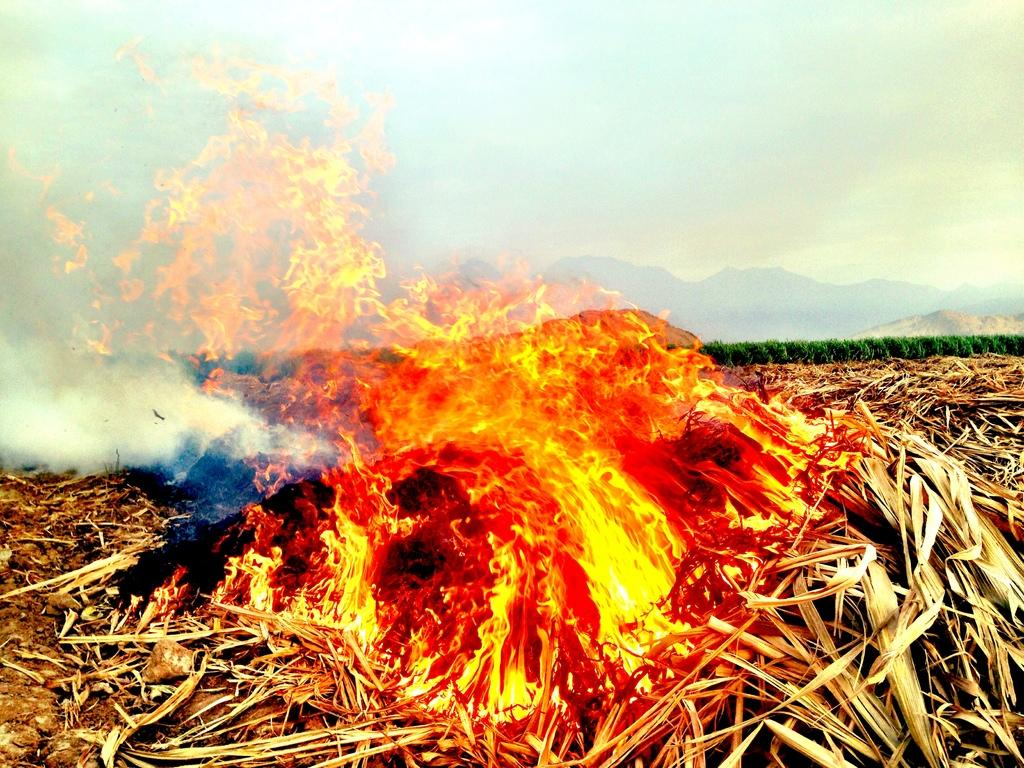What type of surface can be seen in the image? There is ground visible in the image. What is happening to the dry leaves in the image? Dry leaves with fire are present in the image. What is the result of the fire in the image? Smoke is visible in the image. What type of vegetation is present in the image? There are plants in the image. What type of geographical feature can be seen in the image? Mountains are present in the image. What is visible above the ground and plants in the image? The sky is visible in the image. What is the title of the goose in the image? There is no goose present in the image. What account number is associated with the plants in the image? There is no account number associated with the plants in the image. 